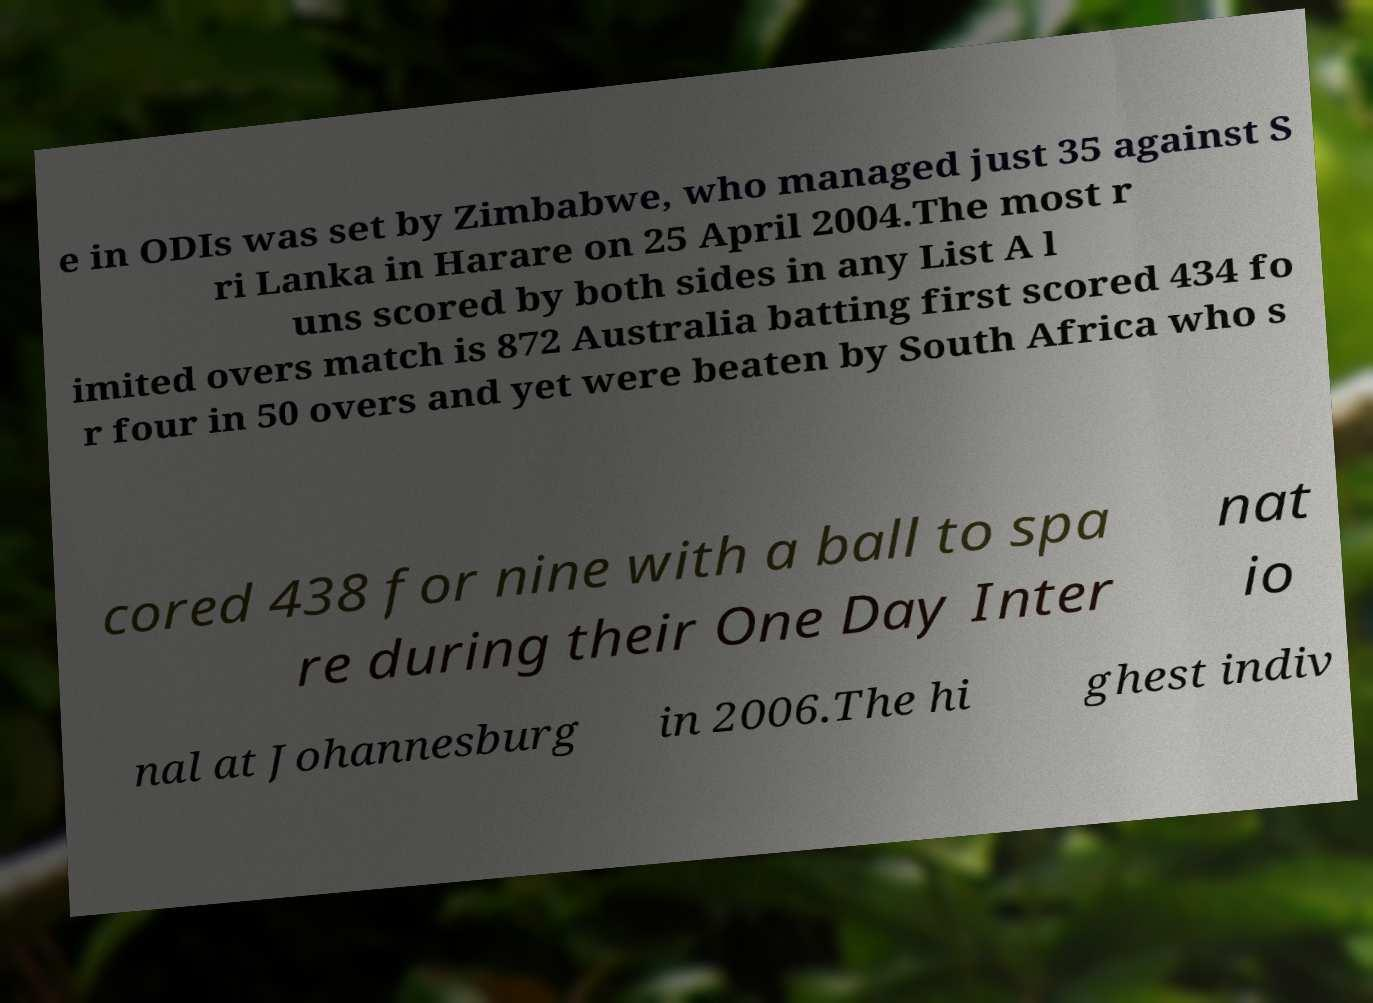Could you assist in decoding the text presented in this image and type it out clearly? e in ODIs was set by Zimbabwe, who managed just 35 against S ri Lanka in Harare on 25 April 2004.The most r uns scored by both sides in any List A l imited overs match is 872 Australia batting first scored 434 fo r four in 50 overs and yet were beaten by South Africa who s cored 438 for nine with a ball to spa re during their One Day Inter nat io nal at Johannesburg in 2006.The hi ghest indiv 